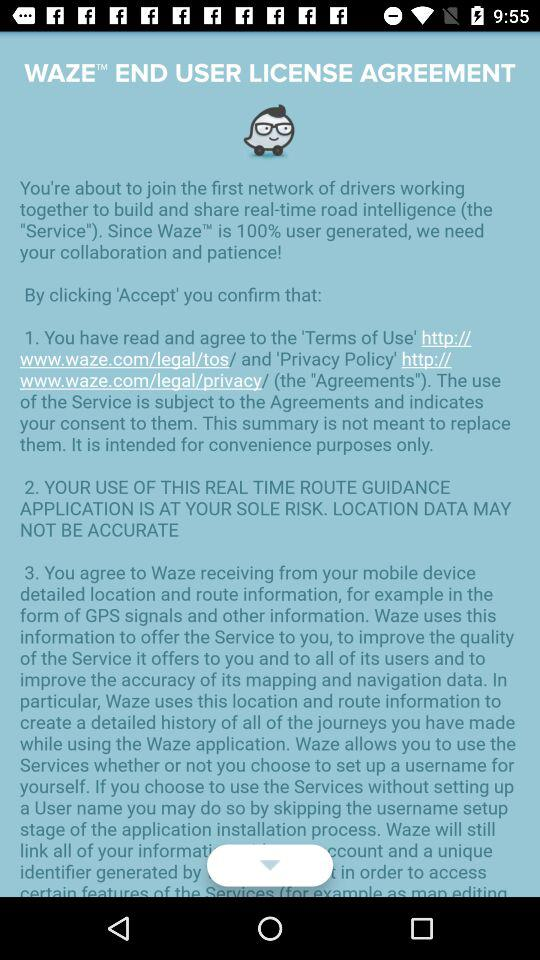How many terms of use does the user need to agree to?
Answer the question using a single word or phrase. 2 